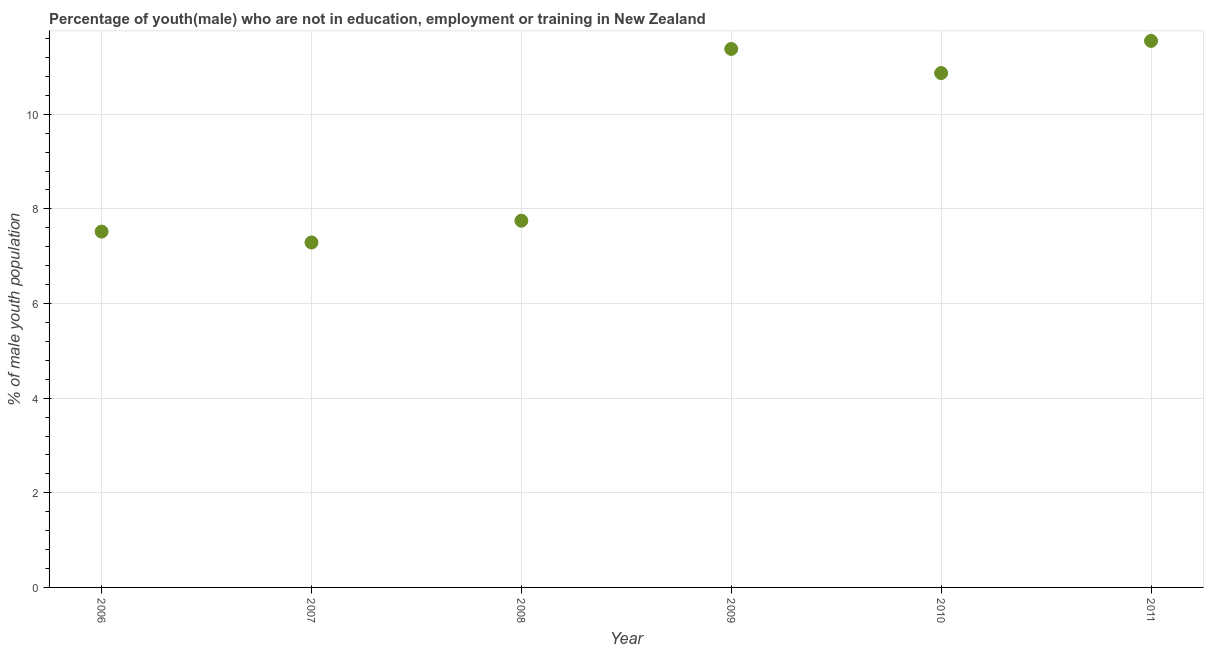What is the unemployed male youth population in 2010?
Give a very brief answer. 10.87. Across all years, what is the maximum unemployed male youth population?
Your answer should be compact. 11.55. Across all years, what is the minimum unemployed male youth population?
Your answer should be very brief. 7.29. In which year was the unemployed male youth population maximum?
Keep it short and to the point. 2011. In which year was the unemployed male youth population minimum?
Offer a terse response. 2007. What is the sum of the unemployed male youth population?
Provide a succinct answer. 56.36. What is the difference between the unemployed male youth population in 2007 and 2008?
Make the answer very short. -0.46. What is the average unemployed male youth population per year?
Offer a terse response. 9.39. What is the median unemployed male youth population?
Ensure brevity in your answer.  9.31. In how many years, is the unemployed male youth population greater than 6.4 %?
Give a very brief answer. 6. Do a majority of the years between 2006 and 2008 (inclusive) have unemployed male youth population greater than 5.2 %?
Provide a succinct answer. Yes. What is the ratio of the unemployed male youth population in 2006 to that in 2011?
Your answer should be very brief. 0.65. What is the difference between the highest and the second highest unemployed male youth population?
Offer a terse response. 0.17. Is the sum of the unemployed male youth population in 2007 and 2009 greater than the maximum unemployed male youth population across all years?
Keep it short and to the point. Yes. What is the difference between the highest and the lowest unemployed male youth population?
Provide a succinct answer. 4.26. In how many years, is the unemployed male youth population greater than the average unemployed male youth population taken over all years?
Your answer should be compact. 3. Does the unemployed male youth population monotonically increase over the years?
Ensure brevity in your answer.  No. What is the difference between two consecutive major ticks on the Y-axis?
Give a very brief answer. 2. Are the values on the major ticks of Y-axis written in scientific E-notation?
Provide a succinct answer. No. Does the graph contain any zero values?
Keep it short and to the point. No. What is the title of the graph?
Your response must be concise. Percentage of youth(male) who are not in education, employment or training in New Zealand. What is the label or title of the X-axis?
Make the answer very short. Year. What is the label or title of the Y-axis?
Give a very brief answer. % of male youth population. What is the % of male youth population in 2006?
Offer a terse response. 7.52. What is the % of male youth population in 2007?
Your answer should be very brief. 7.29. What is the % of male youth population in 2008?
Keep it short and to the point. 7.75. What is the % of male youth population in 2009?
Your response must be concise. 11.38. What is the % of male youth population in 2010?
Offer a very short reply. 10.87. What is the % of male youth population in 2011?
Your answer should be compact. 11.55. What is the difference between the % of male youth population in 2006 and 2007?
Offer a terse response. 0.23. What is the difference between the % of male youth population in 2006 and 2008?
Your answer should be compact. -0.23. What is the difference between the % of male youth population in 2006 and 2009?
Your answer should be very brief. -3.86. What is the difference between the % of male youth population in 2006 and 2010?
Provide a short and direct response. -3.35. What is the difference between the % of male youth population in 2006 and 2011?
Your response must be concise. -4.03. What is the difference between the % of male youth population in 2007 and 2008?
Give a very brief answer. -0.46. What is the difference between the % of male youth population in 2007 and 2009?
Give a very brief answer. -4.09. What is the difference between the % of male youth population in 2007 and 2010?
Provide a succinct answer. -3.58. What is the difference between the % of male youth population in 2007 and 2011?
Ensure brevity in your answer.  -4.26. What is the difference between the % of male youth population in 2008 and 2009?
Offer a terse response. -3.63. What is the difference between the % of male youth population in 2008 and 2010?
Offer a terse response. -3.12. What is the difference between the % of male youth population in 2009 and 2010?
Give a very brief answer. 0.51. What is the difference between the % of male youth population in 2009 and 2011?
Your answer should be very brief. -0.17. What is the difference between the % of male youth population in 2010 and 2011?
Your answer should be compact. -0.68. What is the ratio of the % of male youth population in 2006 to that in 2007?
Your response must be concise. 1.03. What is the ratio of the % of male youth population in 2006 to that in 2008?
Provide a short and direct response. 0.97. What is the ratio of the % of male youth population in 2006 to that in 2009?
Keep it short and to the point. 0.66. What is the ratio of the % of male youth population in 2006 to that in 2010?
Make the answer very short. 0.69. What is the ratio of the % of male youth population in 2006 to that in 2011?
Your answer should be very brief. 0.65. What is the ratio of the % of male youth population in 2007 to that in 2008?
Your answer should be compact. 0.94. What is the ratio of the % of male youth population in 2007 to that in 2009?
Provide a succinct answer. 0.64. What is the ratio of the % of male youth population in 2007 to that in 2010?
Your response must be concise. 0.67. What is the ratio of the % of male youth population in 2007 to that in 2011?
Your answer should be compact. 0.63. What is the ratio of the % of male youth population in 2008 to that in 2009?
Offer a very short reply. 0.68. What is the ratio of the % of male youth population in 2008 to that in 2010?
Make the answer very short. 0.71. What is the ratio of the % of male youth population in 2008 to that in 2011?
Keep it short and to the point. 0.67. What is the ratio of the % of male youth population in 2009 to that in 2010?
Offer a terse response. 1.05. What is the ratio of the % of male youth population in 2010 to that in 2011?
Provide a short and direct response. 0.94. 